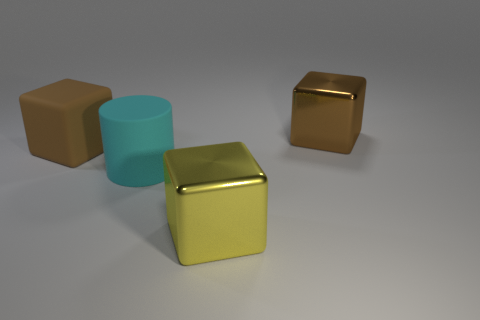Add 2 matte blocks. How many objects exist? 6 Subtract all big brown metallic blocks. How many blocks are left? 2 Subtract all blue cylinders. How many brown cubes are left? 2 Subtract 1 cylinders. How many cylinders are left? 0 Subtract all cylinders. How many objects are left? 3 Subtract all yellow cubes. How many cubes are left? 2 Subtract 0 red balls. How many objects are left? 4 Subtract all blue cylinders. Subtract all blue balls. How many cylinders are left? 1 Subtract all large metallic objects. Subtract all tiny green metal blocks. How many objects are left? 2 Add 2 large rubber blocks. How many large rubber blocks are left? 3 